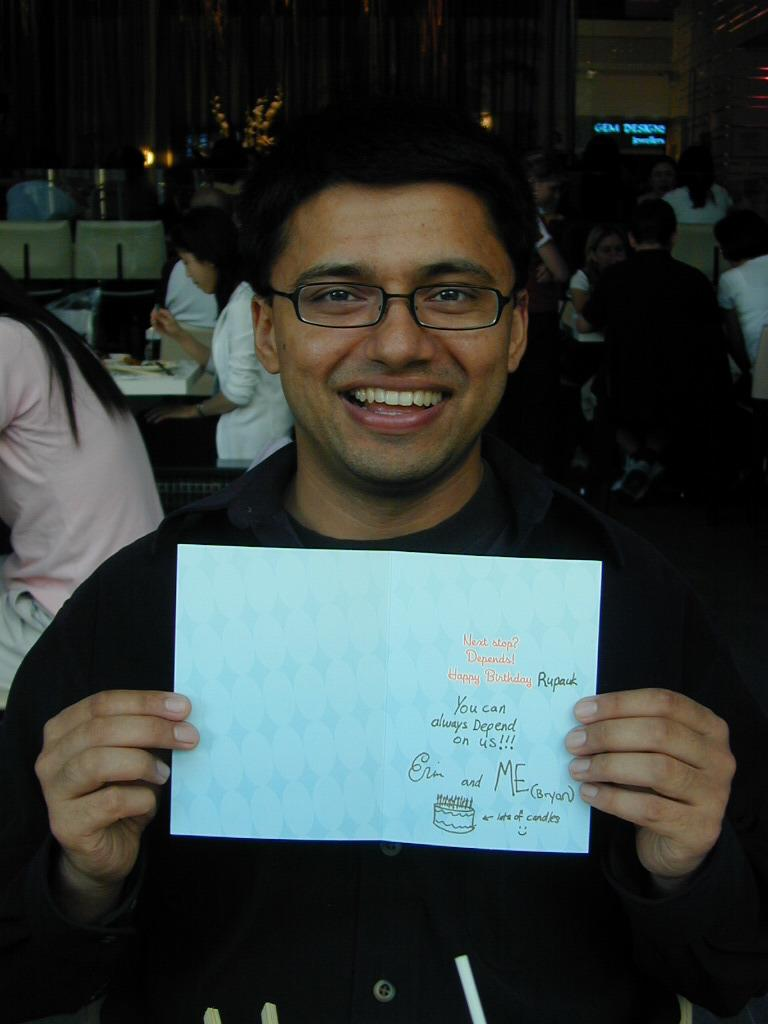What is the person in the foreground of the image holding? The person is holding a card in the image. Can you describe the setting in the background of the image? There are people and a curtain visible in the background of the image. What can be seen illuminating the scene in the image? There are lights visible in the image. What type of skin is visible on the market in the image? There is no market present in the image, and therefore no skin can be observed. 